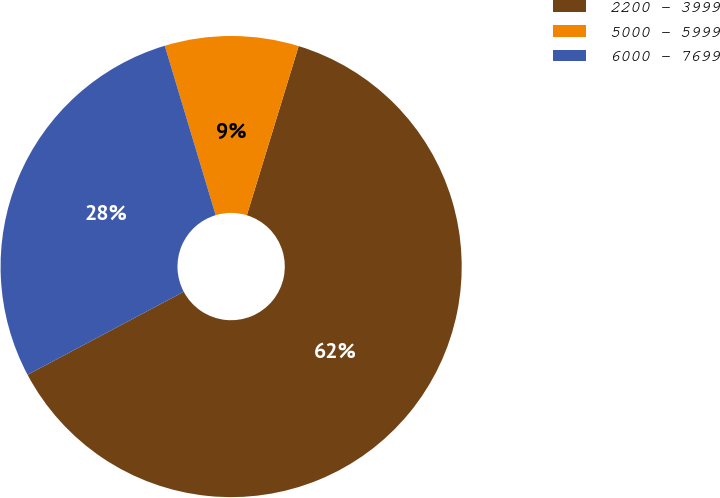<chart> <loc_0><loc_0><loc_500><loc_500><pie_chart><fcel>2200 - 3999<fcel>5000 - 5999<fcel>6000 - 7699<nl><fcel>62.5%<fcel>9.38%<fcel>28.13%<nl></chart> 